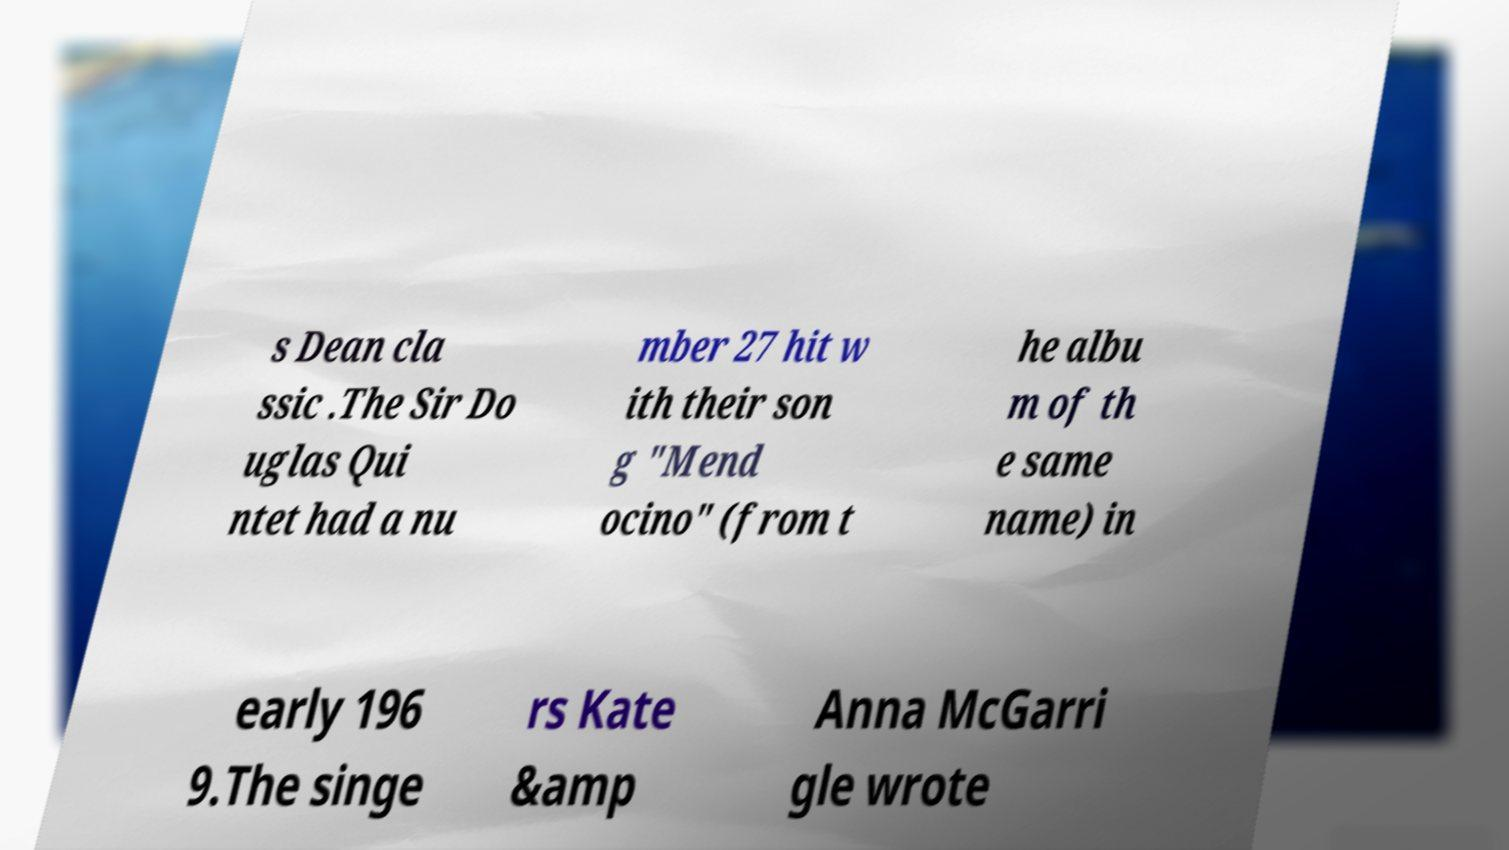Could you assist in decoding the text presented in this image and type it out clearly? s Dean cla ssic .The Sir Do uglas Qui ntet had a nu mber 27 hit w ith their son g "Mend ocino" (from t he albu m of th e same name) in early 196 9.The singe rs Kate &amp Anna McGarri gle wrote 